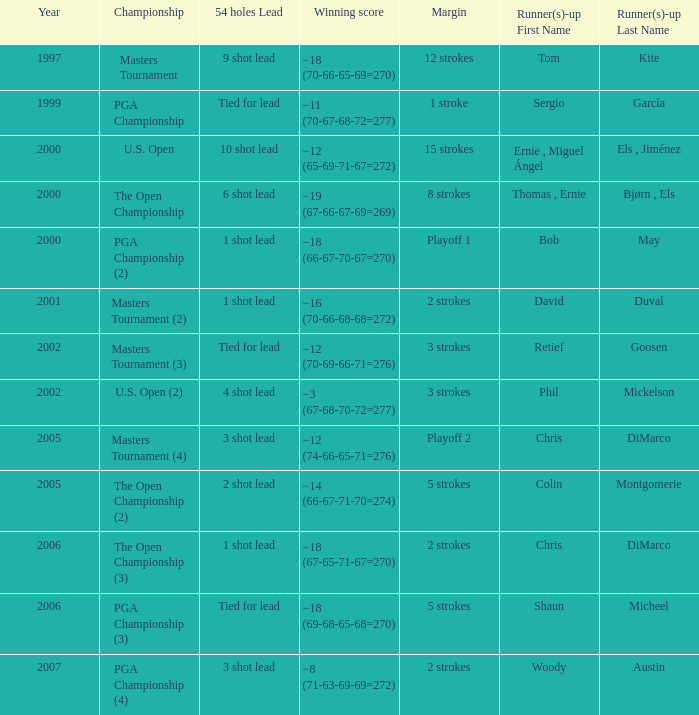 what's the 54 holes where winning score is −19 (67-66-67-69=269) 6 shot lead. 